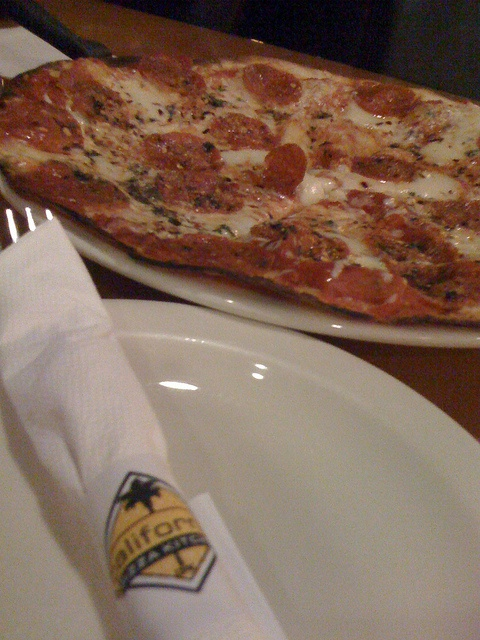Describe the objects in this image and their specific colors. I can see pizza in black, maroon, gray, and brown tones and fork in black, white, darkgray, and gray tones in this image. 